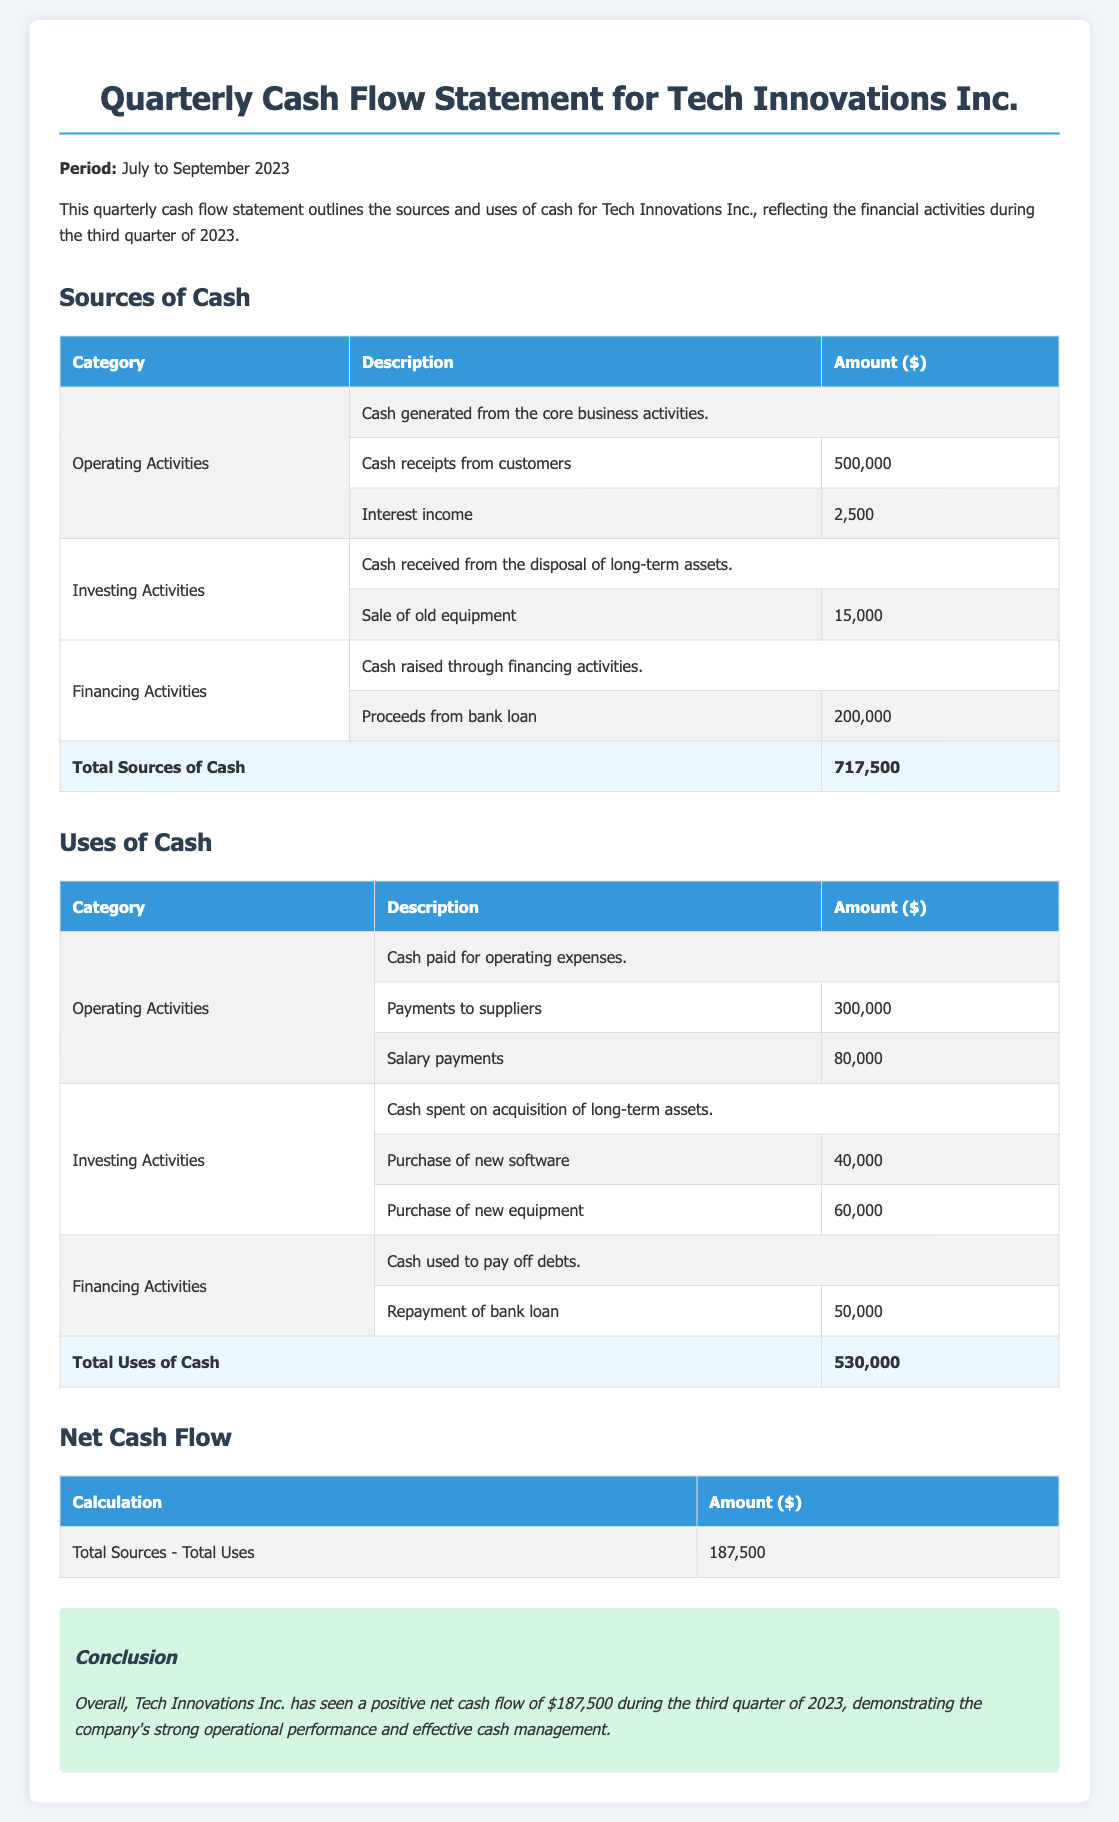What was the period covered by the cash flow statement? The period covered in the document is specified at the beginning, which is July to September 2023.
Answer: July to September 2023 What is the total amount of cash generated from operating activities? The total cash generated from operating activities is found by summing the cash receipts from customers and interest income, which is $500,000 + $2,500.
Answer: $502,500 How much was received from the sale of old equipment? The specific amount received from the sale of old equipment is listed in the investing activities section as $15,000.
Answer: $15,000 What is the total cash used in operating activities? The total cash used in operating activities is the sum of payments to suppliers and salary payments, which is $300,000 + $80,000.
Answer: $380,000 What is the net cash flow for the third quarter of 2023? The net cash flow is calculated as the total sources of cash minus the total uses of cash, which is $717,500 - $530,000.
Answer: $187,500 What amount was paid for the purchase of new equipment? The amount paid for the purchase of new equipment is specified in the investing section as $60,000.
Answer: $60,000 What category represents cash raised through financing activities? The category mentioned for cash raised through financing activities is listed in the document as Financing Activities.
Answer: Financing Activities What is the total amount of cash used in financing activities? The total cash used in financing activities includes repayment of the bank loan mentioned in the document, which is $50,000.
Answer: $50,000 What overall conclusion is made in the cash flow statement? The overall conclusion presented summarizes the positive performance and management, stating a positive net cash flow.
Answer: Positive net cash flow of $187,500 